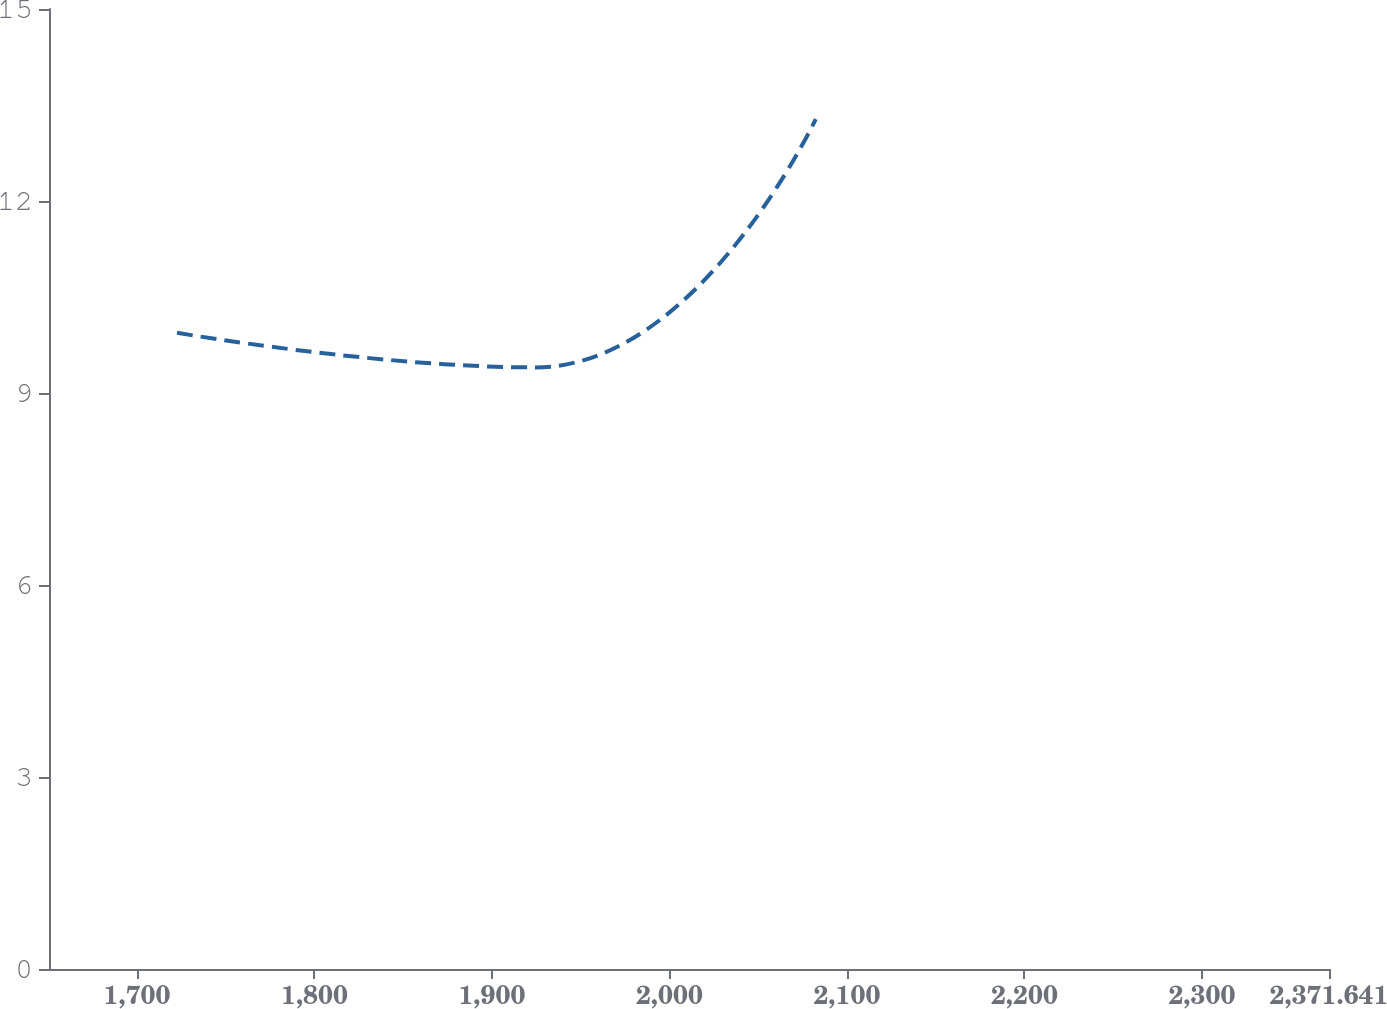Convert chart to OTSL. <chart><loc_0><loc_0><loc_500><loc_500><line_chart><ecel><fcel>Estimated Future Benefit Payments<nl><fcel>1722.57<fcel>9.94<nl><fcel>1924.59<fcel>9.4<nl><fcel>2082.46<fcel>13.28<nl><fcel>2376.42<fcel>14.81<nl><fcel>2443.76<fcel>12.52<nl></chart> 